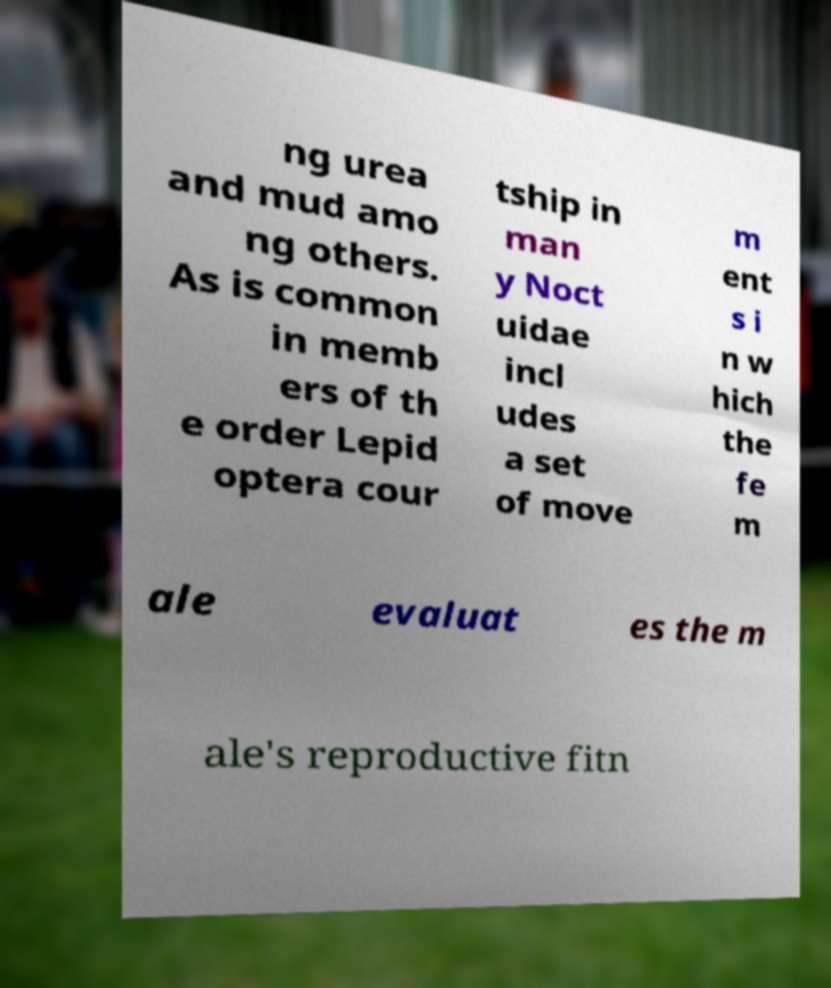I need the written content from this picture converted into text. Can you do that? ng urea and mud amo ng others. As is common in memb ers of th e order Lepid optera cour tship in man y Noct uidae incl udes a set of move m ent s i n w hich the fe m ale evaluat es the m ale's reproductive fitn 